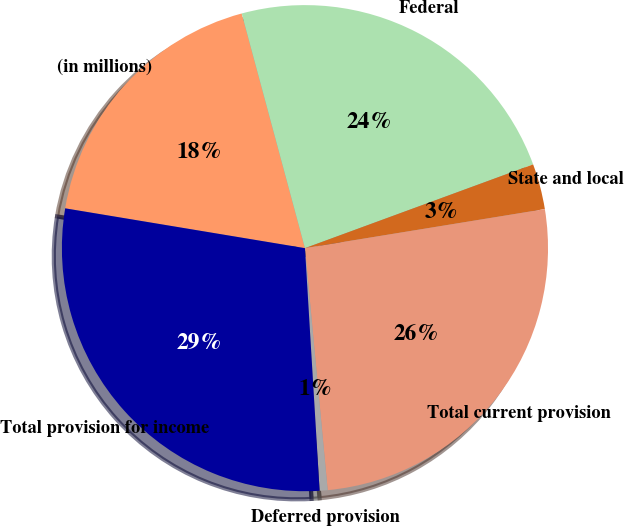Convert chart to OTSL. <chart><loc_0><loc_0><loc_500><loc_500><pie_chart><fcel>(in millions)<fcel>Federal<fcel>State and local<fcel>Total current provision<fcel>Deferred provision<fcel>Total provision for income<nl><fcel>18.19%<fcel>23.59%<fcel>3.03%<fcel>26.08%<fcel>0.53%<fcel>28.58%<nl></chart> 